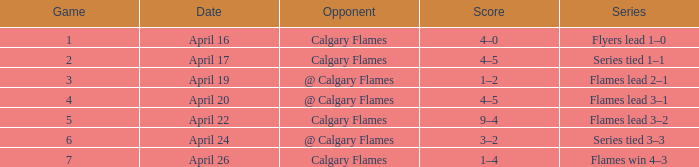When does a game with a score of 4-5 occur, and has a size under 4? April 17. I'm looking to parse the entire table for insights. Could you assist me with that? {'header': ['Game', 'Date', 'Opponent', 'Score', 'Series'], 'rows': [['1', 'April 16', 'Calgary Flames', '4–0', 'Flyers lead 1–0'], ['2', 'April 17', 'Calgary Flames', '4–5', 'Series tied 1–1'], ['3', 'April 19', '@ Calgary Flames', '1–2', 'Flames lead 2–1'], ['4', 'April 20', '@ Calgary Flames', '4–5', 'Flames lead 3–1'], ['5', 'April 22', 'Calgary Flames', '9–4', 'Flames lead 3–2'], ['6', 'April 24', '@ Calgary Flames', '3–2', 'Series tied 3–3'], ['7', 'April 26', 'Calgary Flames', '1–4', 'Flames win 4–3']]} 